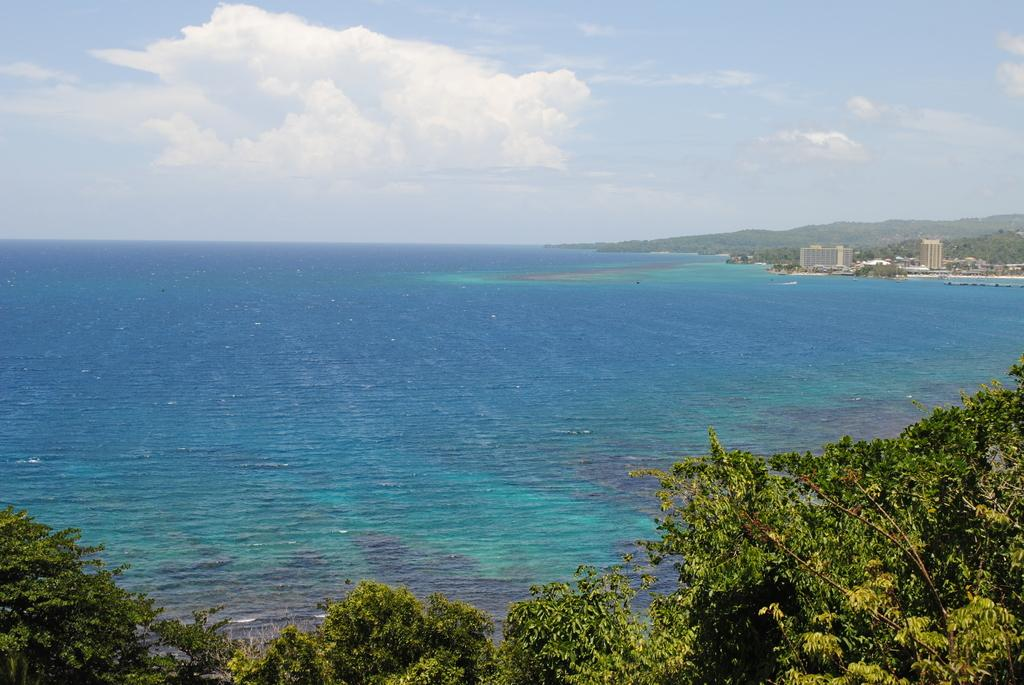What is located in the middle of the image? There is water in the middle of the image. What type of vegetation is at the bottom of the image? There are trees at the bottom of the image. What type of structures are on the right side of the image? There are buildings on the right side of the image. What is visible at the top of the image? The sky is visible at the top of the image. What level of excitement can be seen in the town in the image? There is no town present in the image, so it is not possible to determine the level of excitement. What things are being done by the people in the image? There are no people present in the image, so it is not possible to determine what things they might be doing. 